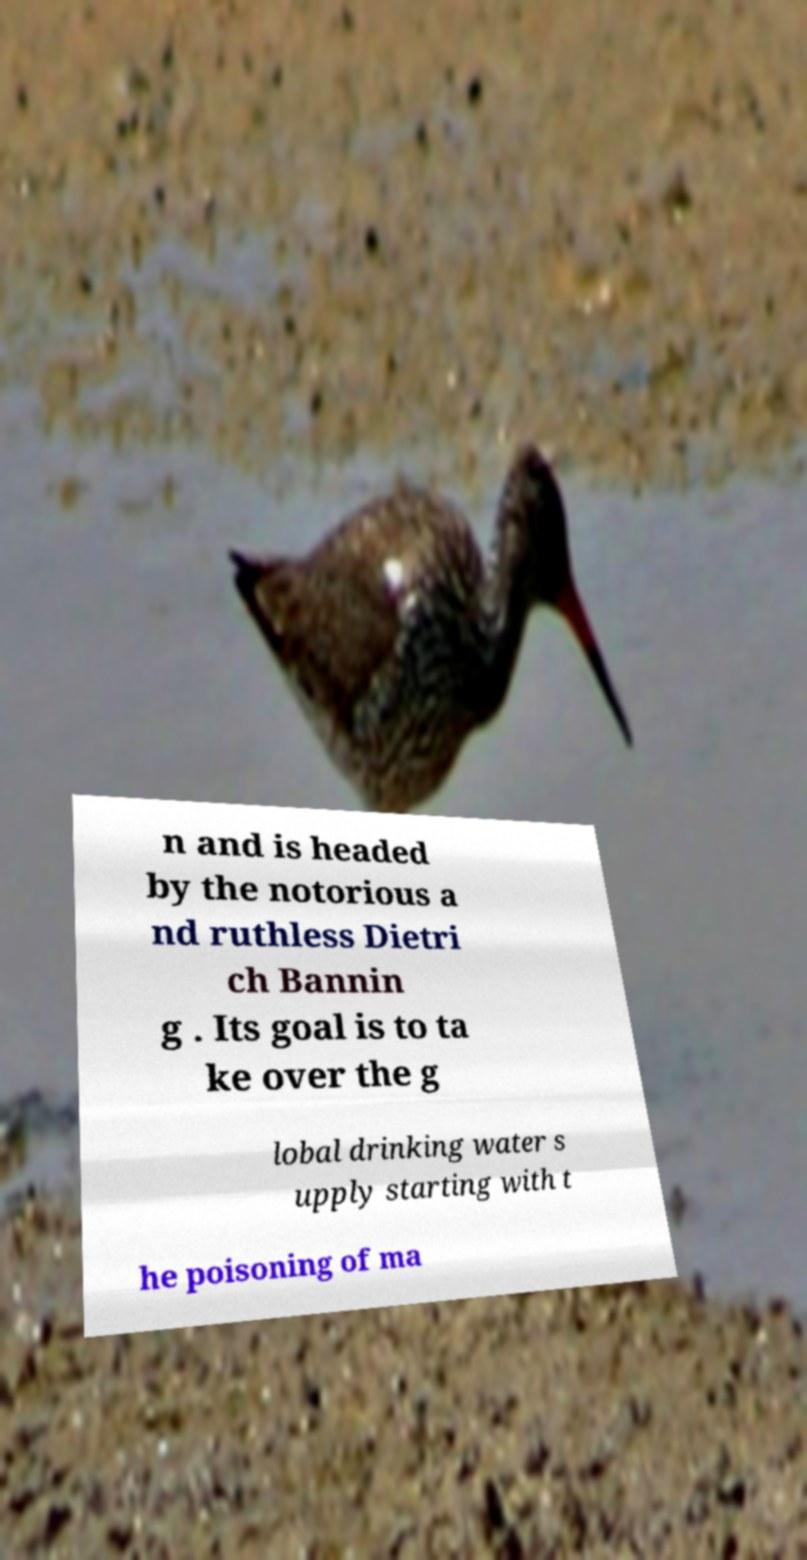I need the written content from this picture converted into text. Can you do that? n and is headed by the notorious a nd ruthless Dietri ch Bannin g . Its goal is to ta ke over the g lobal drinking water s upply starting with t he poisoning of ma 